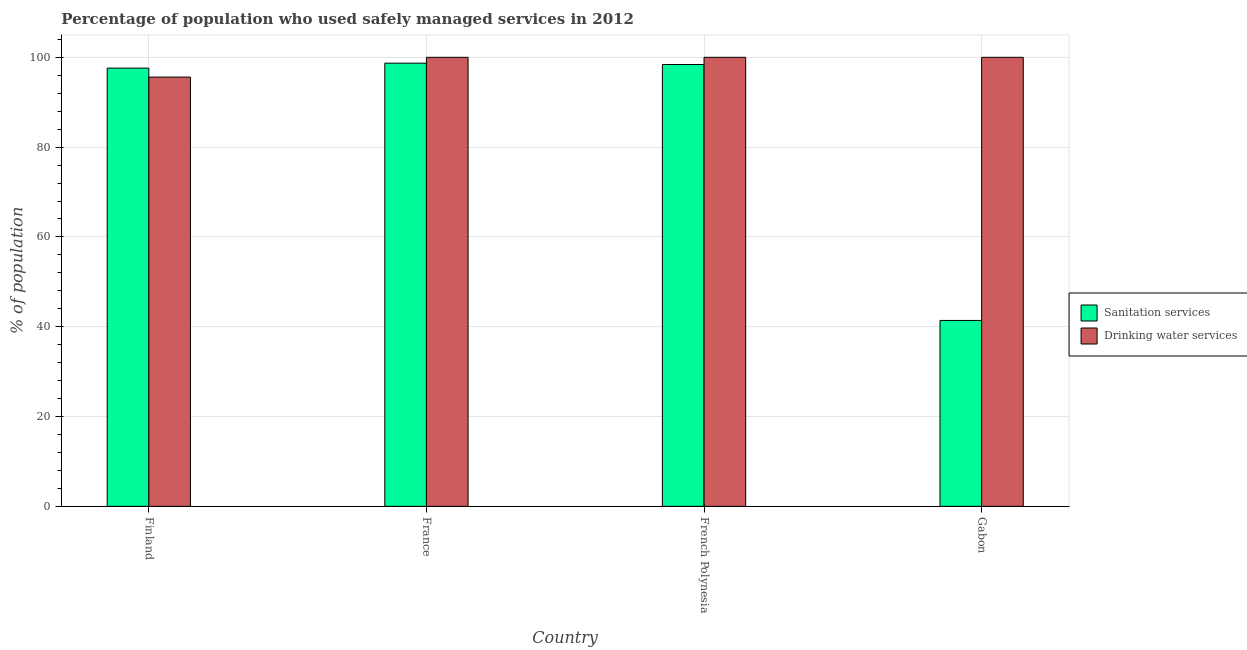How many different coloured bars are there?
Offer a terse response. 2. How many groups of bars are there?
Your answer should be very brief. 4. Are the number of bars on each tick of the X-axis equal?
Your answer should be very brief. Yes. How many bars are there on the 4th tick from the left?
Provide a short and direct response. 2. What is the label of the 2nd group of bars from the left?
Offer a terse response. France. What is the percentage of population who used drinking water services in French Polynesia?
Your answer should be compact. 100. Across all countries, what is the maximum percentage of population who used drinking water services?
Offer a very short reply. 100. Across all countries, what is the minimum percentage of population who used drinking water services?
Ensure brevity in your answer.  95.6. In which country was the percentage of population who used drinking water services maximum?
Your answer should be compact. France. In which country was the percentage of population who used sanitation services minimum?
Offer a terse response. Gabon. What is the total percentage of population who used sanitation services in the graph?
Your answer should be compact. 336.1. What is the difference between the percentage of population who used drinking water services in Finland and that in French Polynesia?
Your answer should be compact. -4.4. What is the difference between the percentage of population who used drinking water services in Gabon and the percentage of population who used sanitation services in Finland?
Your response must be concise. 2.4. What is the average percentage of population who used drinking water services per country?
Your response must be concise. 98.9. What is the difference between the percentage of population who used sanitation services and percentage of population who used drinking water services in Gabon?
Make the answer very short. -58.6. What is the ratio of the percentage of population who used sanitation services in France to that in French Polynesia?
Provide a succinct answer. 1. Is the percentage of population who used sanitation services in France less than that in French Polynesia?
Your answer should be compact. No. Is the difference between the percentage of population who used sanitation services in French Polynesia and Gabon greater than the difference between the percentage of population who used drinking water services in French Polynesia and Gabon?
Provide a succinct answer. Yes. What is the difference between the highest and the second highest percentage of population who used sanitation services?
Your answer should be very brief. 0.3. What is the difference between the highest and the lowest percentage of population who used sanitation services?
Offer a terse response. 57.3. What does the 2nd bar from the left in Finland represents?
Provide a short and direct response. Drinking water services. What does the 2nd bar from the right in French Polynesia represents?
Your answer should be compact. Sanitation services. Are all the bars in the graph horizontal?
Offer a terse response. No. How many countries are there in the graph?
Provide a succinct answer. 4. What is the difference between two consecutive major ticks on the Y-axis?
Your answer should be compact. 20. Does the graph contain grids?
Your response must be concise. Yes. How are the legend labels stacked?
Your answer should be compact. Vertical. What is the title of the graph?
Offer a very short reply. Percentage of population who used safely managed services in 2012. What is the label or title of the X-axis?
Your answer should be very brief. Country. What is the label or title of the Y-axis?
Your answer should be very brief. % of population. What is the % of population in Sanitation services in Finland?
Offer a terse response. 97.6. What is the % of population in Drinking water services in Finland?
Provide a succinct answer. 95.6. What is the % of population of Sanitation services in France?
Your answer should be compact. 98.7. What is the % of population of Drinking water services in France?
Provide a short and direct response. 100. What is the % of population in Sanitation services in French Polynesia?
Provide a short and direct response. 98.4. What is the % of population of Sanitation services in Gabon?
Offer a very short reply. 41.4. What is the % of population of Drinking water services in Gabon?
Your answer should be compact. 100. Across all countries, what is the maximum % of population of Sanitation services?
Provide a short and direct response. 98.7. Across all countries, what is the maximum % of population in Drinking water services?
Offer a very short reply. 100. Across all countries, what is the minimum % of population of Sanitation services?
Ensure brevity in your answer.  41.4. Across all countries, what is the minimum % of population of Drinking water services?
Offer a very short reply. 95.6. What is the total % of population of Sanitation services in the graph?
Provide a short and direct response. 336.1. What is the total % of population in Drinking water services in the graph?
Your answer should be very brief. 395.6. What is the difference between the % of population in Sanitation services in Finland and that in France?
Keep it short and to the point. -1.1. What is the difference between the % of population of Sanitation services in Finland and that in French Polynesia?
Give a very brief answer. -0.8. What is the difference between the % of population of Drinking water services in Finland and that in French Polynesia?
Ensure brevity in your answer.  -4.4. What is the difference between the % of population of Sanitation services in Finland and that in Gabon?
Your answer should be compact. 56.2. What is the difference between the % of population in Drinking water services in France and that in French Polynesia?
Provide a succinct answer. 0. What is the difference between the % of population of Sanitation services in France and that in Gabon?
Your answer should be compact. 57.3. What is the difference between the % of population in Drinking water services in France and that in Gabon?
Your answer should be compact. 0. What is the difference between the % of population in Sanitation services in French Polynesia and that in Gabon?
Make the answer very short. 57. What is the difference between the % of population of Sanitation services in Finland and the % of population of Drinking water services in French Polynesia?
Ensure brevity in your answer.  -2.4. What is the difference between the % of population of Sanitation services in Finland and the % of population of Drinking water services in Gabon?
Give a very brief answer. -2.4. What is the difference between the % of population in Sanitation services in France and the % of population in Drinking water services in French Polynesia?
Give a very brief answer. -1.3. What is the difference between the % of population in Sanitation services in French Polynesia and the % of population in Drinking water services in Gabon?
Offer a very short reply. -1.6. What is the average % of population in Sanitation services per country?
Provide a succinct answer. 84.03. What is the average % of population of Drinking water services per country?
Ensure brevity in your answer.  98.9. What is the difference between the % of population of Sanitation services and % of population of Drinking water services in Finland?
Keep it short and to the point. 2. What is the difference between the % of population of Sanitation services and % of population of Drinking water services in French Polynesia?
Provide a succinct answer. -1.6. What is the difference between the % of population in Sanitation services and % of population in Drinking water services in Gabon?
Give a very brief answer. -58.6. What is the ratio of the % of population in Sanitation services in Finland to that in France?
Offer a terse response. 0.99. What is the ratio of the % of population of Drinking water services in Finland to that in France?
Offer a very short reply. 0.96. What is the ratio of the % of population in Drinking water services in Finland to that in French Polynesia?
Provide a short and direct response. 0.96. What is the ratio of the % of population of Sanitation services in Finland to that in Gabon?
Your answer should be very brief. 2.36. What is the ratio of the % of population of Drinking water services in Finland to that in Gabon?
Keep it short and to the point. 0.96. What is the ratio of the % of population of Sanitation services in France to that in Gabon?
Keep it short and to the point. 2.38. What is the ratio of the % of population in Sanitation services in French Polynesia to that in Gabon?
Make the answer very short. 2.38. What is the difference between the highest and the lowest % of population of Sanitation services?
Your response must be concise. 57.3. What is the difference between the highest and the lowest % of population in Drinking water services?
Keep it short and to the point. 4.4. 